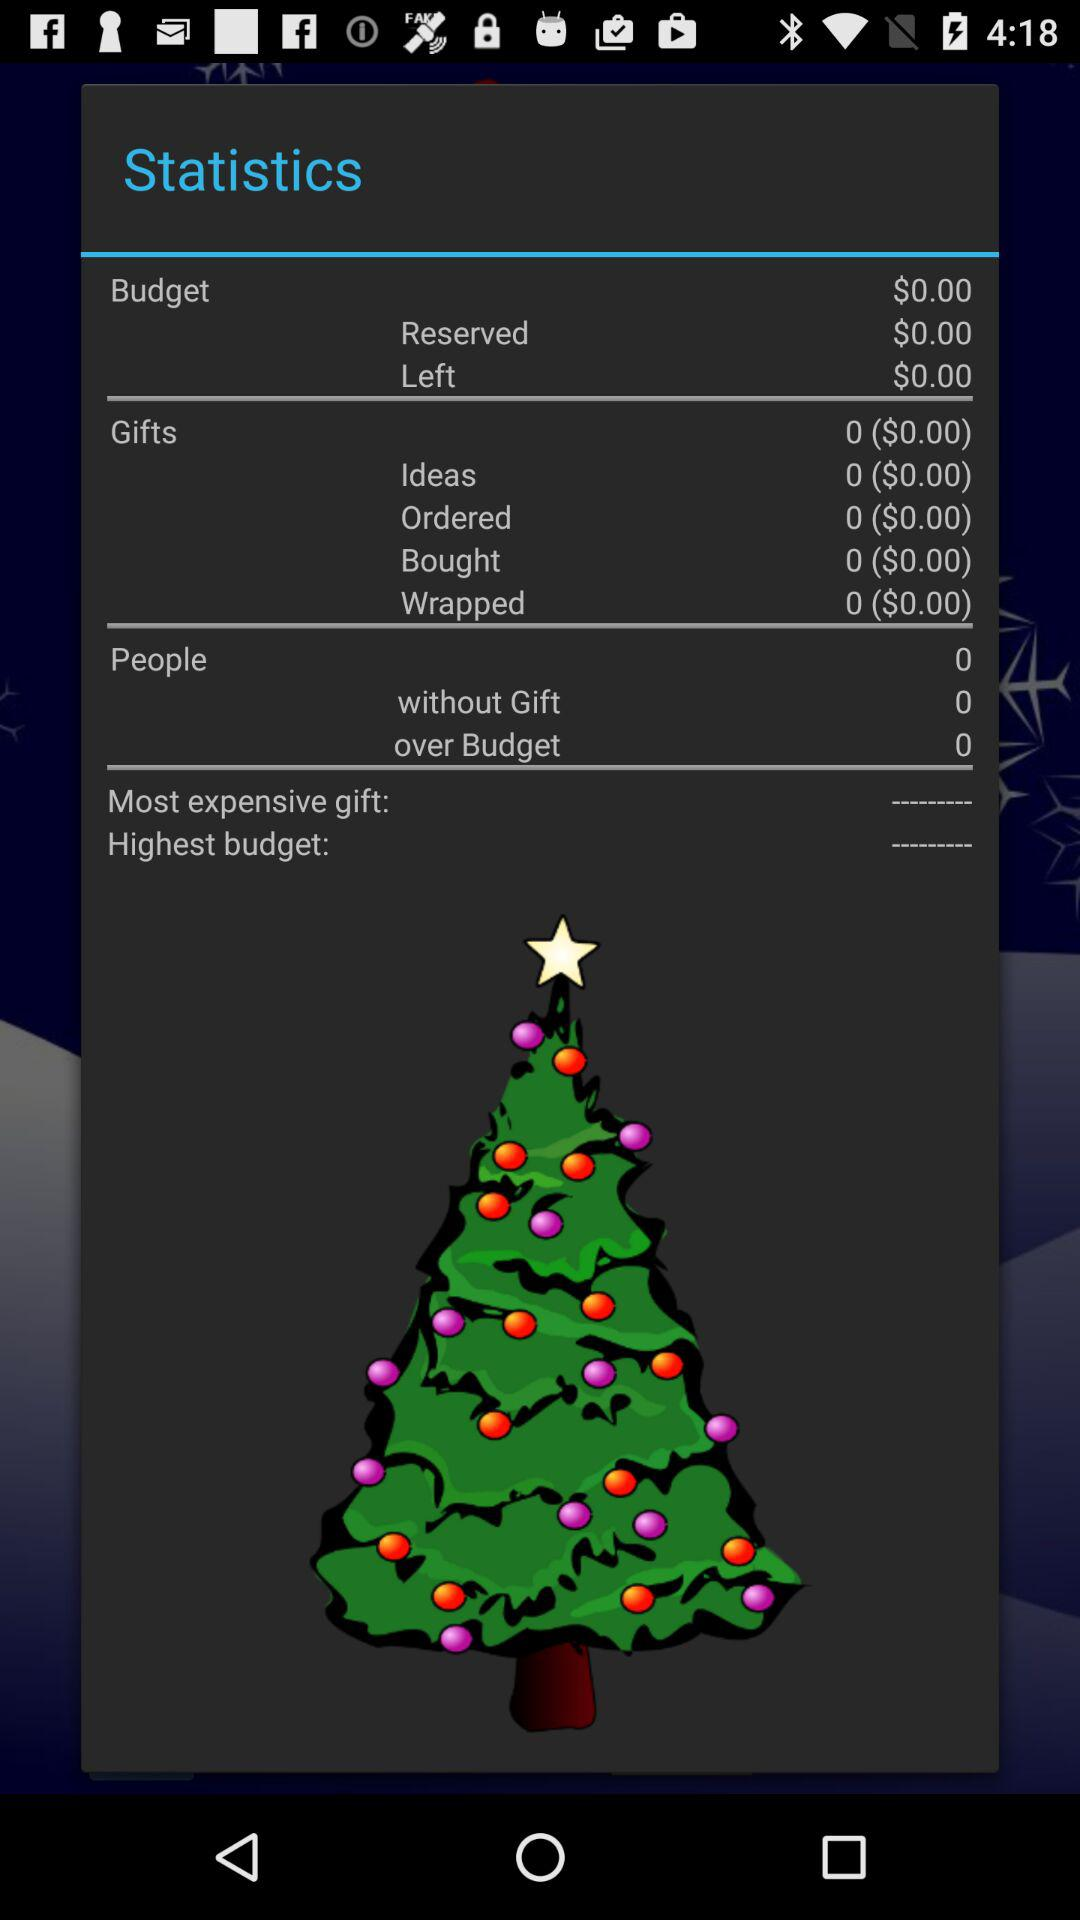How many reserved budget are there?
When the provided information is insufficient, respond with <no answer>. <no answer> 